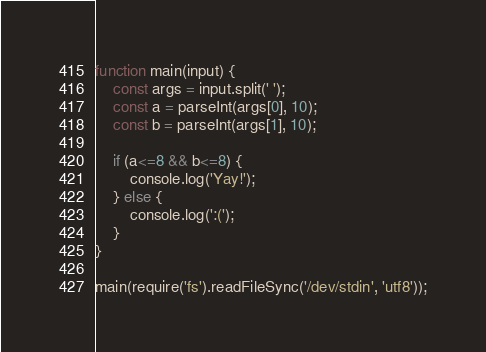Convert code to text. <code><loc_0><loc_0><loc_500><loc_500><_JavaScript_>function main(input) {
    const args = input.split(' ');
    const a = parseInt(args[0], 10);
    const b = parseInt(args[1], 10);

    if (a<=8 && b<=8) {
        console.log('Yay!');
    } else {
        console.log(':(');
    }
}

main(require('fs').readFileSync('/dev/stdin', 'utf8'));</code> 